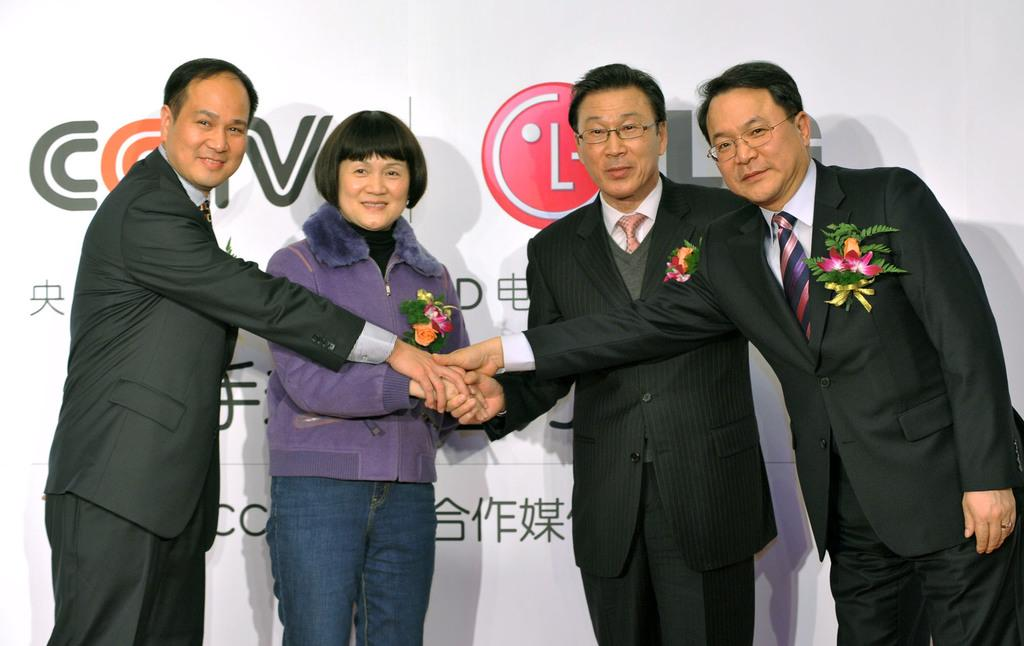What can be seen in the foreground of the image? There are people in the foreground of the image. What are the people holding in their hands? The people are holding flowers in their hands. What is located in the background of the image? There is a poster in the background of the image. What is written or depicted on the poster? There is text on the poster. How many passengers are visible in the image? There is no reference to passengers in the image; it features people holding flowers and a poster in the background. What type of motion is being depicted in the image? There is no motion depicted in the image; it is a still scene featuring people holding flowers and a poster in the background. 